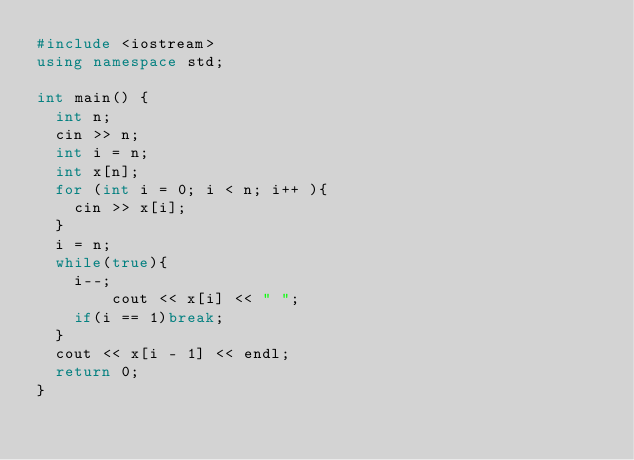Convert code to text. <code><loc_0><loc_0><loc_500><loc_500><_C++_>#include <iostream>
using namespace std;

int main() {
	int n;
	cin >> n;
	int i = n;
	int x[n];
	for (int i = 0; i < n; i++ ){
		cin >> x[i];
	}
	i = n;
	while(true){
		i--;
        cout << x[i] << " ";
		if(i == 1)break;
	}
	cout << x[i - 1] << endl;
	return 0;
}</code> 